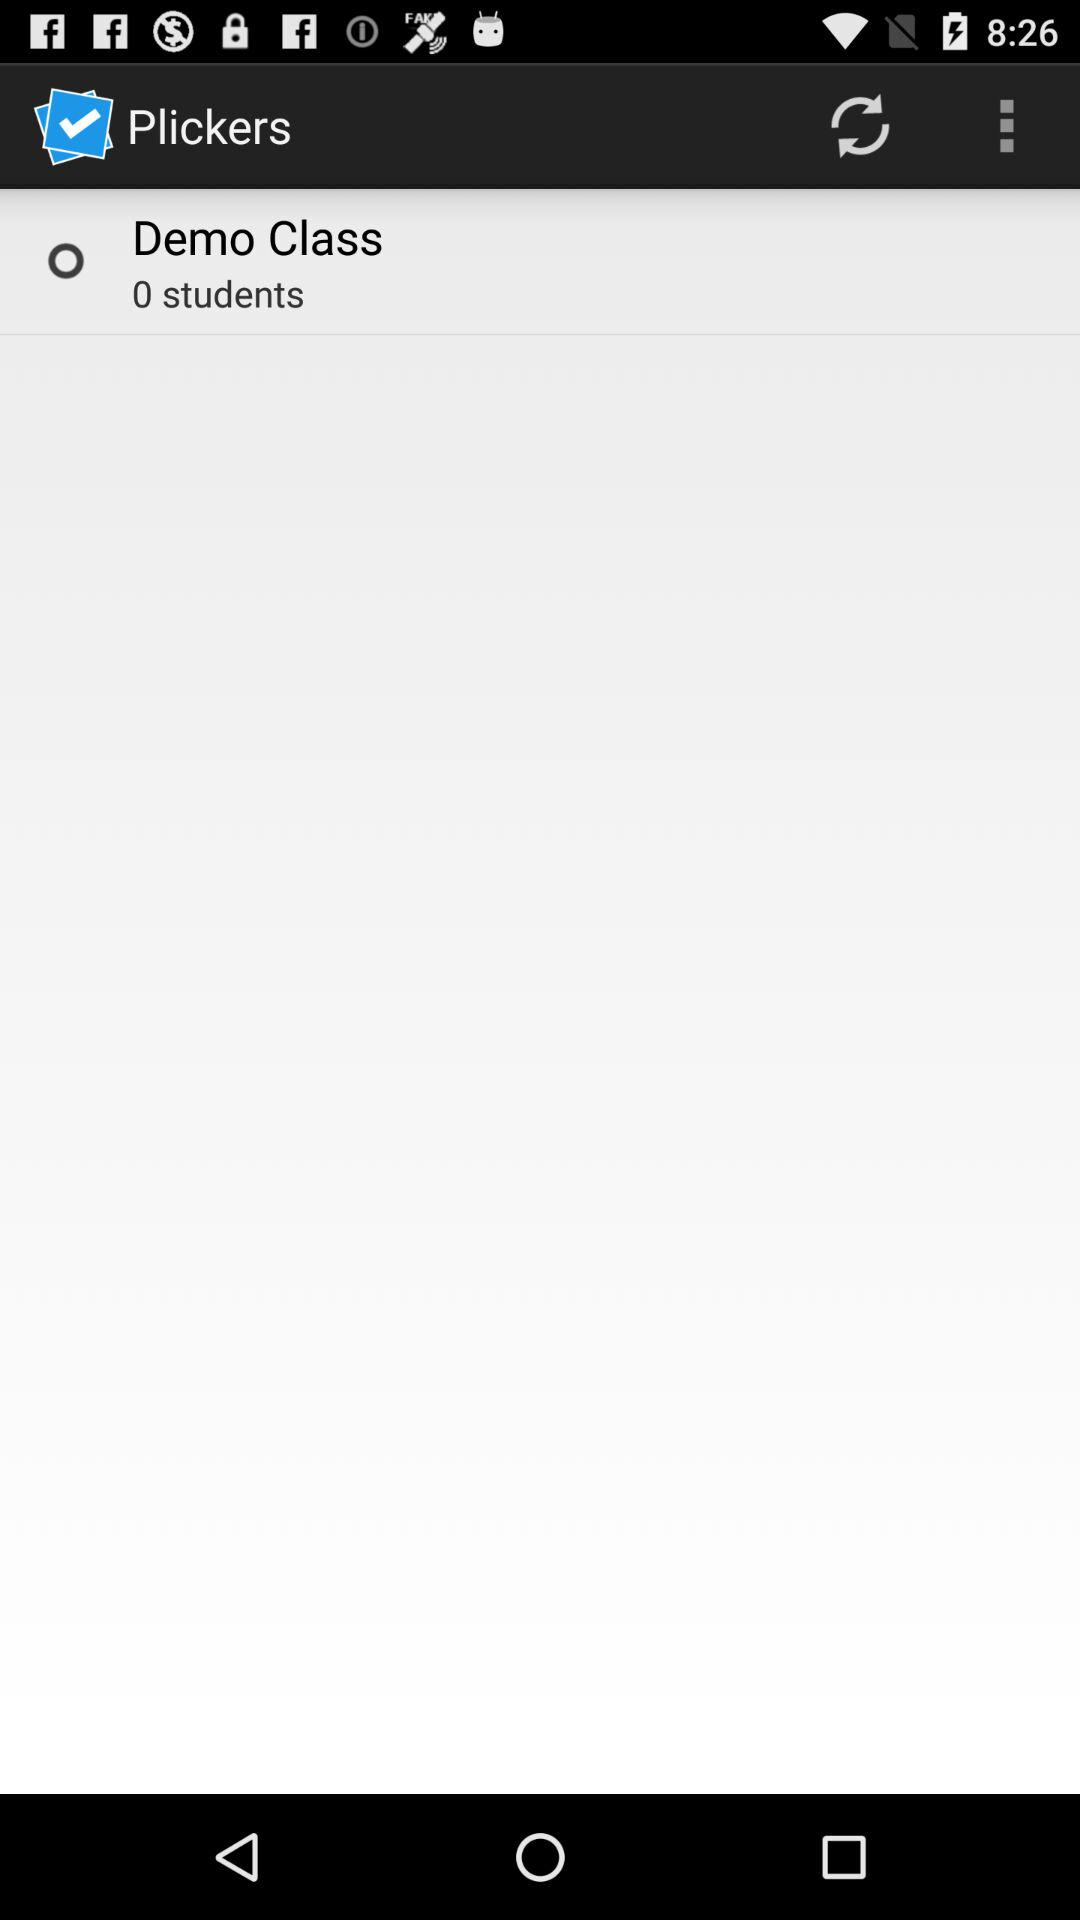What is the application name? The application name is "Plickers". 